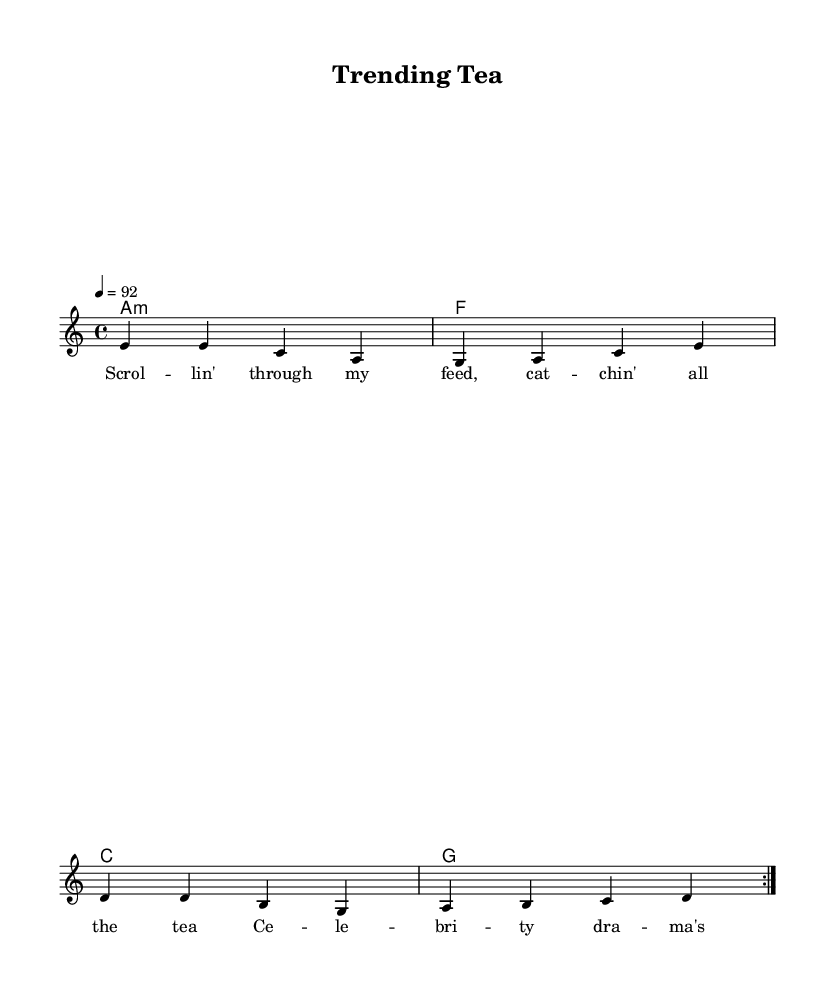What is the key signature of this music? The key signature is A minor, which is indicated by the absence of sharps or flats and is specified at the beginning of the sheet music.
Answer: A minor What is the time signature of this music? The time signature is 4/4, which is marked at the beginning and signifies there are four beats in a measure, with a quarter note receiving one beat.
Answer: 4/4 What is the tempo marking for this piece? The tempo marking is 92 beats per minute, indicated by the notation "4 = 92" at the beginning of the score, which designates the speed of the music.
Answer: 92 How many measures are repeated in the melody? There are 2 measures that are repeated in the melody, as indicated by the "repeat volta 2" notation.
Answer: 2 What is the type of the piece? This piece is a rap song, as reflected in the lyrics and themes expressed in the title "Trending Tea," which focuses on celebrity gossip and pop culture.
Answer: Rap What is the first line of the lyrics? The first line of the lyrics is "Scrol -- lin' through my feed, cat -- chin' all the tea," as noted in the lyric section corresponding to the melody.
Answer: Scrol -- lin' through my feed, cat -- chin' all the tea What type of chords are primarily used in this piece? The chords used in this piece include minor and major chords, with the specific chords indicated being A minor, F major, C major, and G major.
Answer: Minor and major chords 